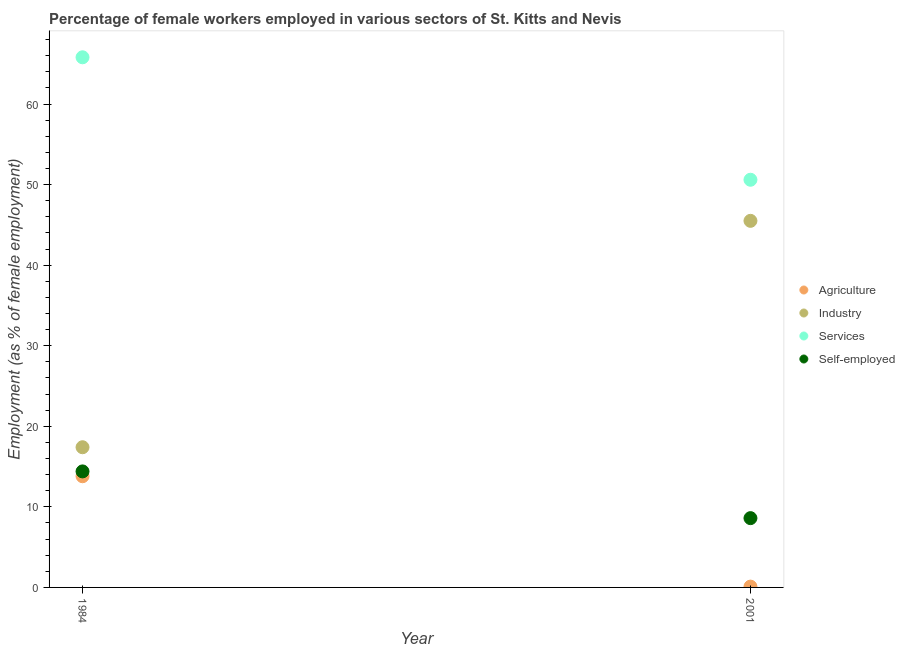Is the number of dotlines equal to the number of legend labels?
Give a very brief answer. Yes. What is the percentage of female workers in services in 1984?
Make the answer very short. 65.8. Across all years, what is the maximum percentage of female workers in industry?
Your response must be concise. 45.5. Across all years, what is the minimum percentage of self employed female workers?
Offer a very short reply. 8.6. In which year was the percentage of female workers in agriculture minimum?
Ensure brevity in your answer.  2001. What is the total percentage of female workers in agriculture in the graph?
Ensure brevity in your answer.  13.9. What is the difference between the percentage of self employed female workers in 1984 and that in 2001?
Give a very brief answer. 5.8. What is the difference between the percentage of self employed female workers in 2001 and the percentage of female workers in agriculture in 1984?
Provide a succinct answer. -5.2. What is the average percentage of female workers in services per year?
Your response must be concise. 58.2. In the year 2001, what is the difference between the percentage of female workers in services and percentage of self employed female workers?
Your response must be concise. 42. In how many years, is the percentage of female workers in services greater than 46 %?
Offer a terse response. 2. What is the ratio of the percentage of female workers in agriculture in 1984 to that in 2001?
Your answer should be compact. 138. Is the percentage of female workers in services in 1984 less than that in 2001?
Offer a terse response. No. Is it the case that in every year, the sum of the percentage of female workers in agriculture and percentage of female workers in industry is greater than the percentage of female workers in services?
Your answer should be very brief. No. Is the percentage of female workers in industry strictly greater than the percentage of female workers in agriculture over the years?
Offer a very short reply. Yes. Is the percentage of self employed female workers strictly less than the percentage of female workers in services over the years?
Provide a succinct answer. Yes. How many dotlines are there?
Provide a short and direct response. 4. Where does the legend appear in the graph?
Offer a very short reply. Center right. How many legend labels are there?
Your response must be concise. 4. What is the title of the graph?
Give a very brief answer. Percentage of female workers employed in various sectors of St. Kitts and Nevis. What is the label or title of the Y-axis?
Offer a terse response. Employment (as % of female employment). What is the Employment (as % of female employment) of Agriculture in 1984?
Offer a very short reply. 13.8. What is the Employment (as % of female employment) of Industry in 1984?
Your answer should be very brief. 17.4. What is the Employment (as % of female employment) of Services in 1984?
Provide a succinct answer. 65.8. What is the Employment (as % of female employment) in Self-employed in 1984?
Provide a short and direct response. 14.4. What is the Employment (as % of female employment) of Agriculture in 2001?
Your answer should be compact. 0.1. What is the Employment (as % of female employment) in Industry in 2001?
Keep it short and to the point. 45.5. What is the Employment (as % of female employment) of Services in 2001?
Make the answer very short. 50.6. What is the Employment (as % of female employment) in Self-employed in 2001?
Offer a very short reply. 8.6. Across all years, what is the maximum Employment (as % of female employment) in Agriculture?
Offer a terse response. 13.8. Across all years, what is the maximum Employment (as % of female employment) of Industry?
Provide a succinct answer. 45.5. Across all years, what is the maximum Employment (as % of female employment) in Services?
Provide a succinct answer. 65.8. Across all years, what is the maximum Employment (as % of female employment) in Self-employed?
Make the answer very short. 14.4. Across all years, what is the minimum Employment (as % of female employment) in Agriculture?
Your response must be concise. 0.1. Across all years, what is the minimum Employment (as % of female employment) of Industry?
Give a very brief answer. 17.4. Across all years, what is the minimum Employment (as % of female employment) in Services?
Offer a very short reply. 50.6. Across all years, what is the minimum Employment (as % of female employment) in Self-employed?
Provide a short and direct response. 8.6. What is the total Employment (as % of female employment) in Agriculture in the graph?
Provide a short and direct response. 13.9. What is the total Employment (as % of female employment) of Industry in the graph?
Offer a very short reply. 62.9. What is the total Employment (as % of female employment) in Services in the graph?
Offer a terse response. 116.4. What is the total Employment (as % of female employment) of Self-employed in the graph?
Provide a short and direct response. 23. What is the difference between the Employment (as % of female employment) in Industry in 1984 and that in 2001?
Make the answer very short. -28.1. What is the difference between the Employment (as % of female employment) in Self-employed in 1984 and that in 2001?
Make the answer very short. 5.8. What is the difference between the Employment (as % of female employment) of Agriculture in 1984 and the Employment (as % of female employment) of Industry in 2001?
Offer a very short reply. -31.7. What is the difference between the Employment (as % of female employment) of Agriculture in 1984 and the Employment (as % of female employment) of Services in 2001?
Keep it short and to the point. -36.8. What is the difference between the Employment (as % of female employment) of Industry in 1984 and the Employment (as % of female employment) of Services in 2001?
Provide a short and direct response. -33.2. What is the difference between the Employment (as % of female employment) of Services in 1984 and the Employment (as % of female employment) of Self-employed in 2001?
Your answer should be compact. 57.2. What is the average Employment (as % of female employment) of Agriculture per year?
Provide a short and direct response. 6.95. What is the average Employment (as % of female employment) of Industry per year?
Keep it short and to the point. 31.45. What is the average Employment (as % of female employment) of Services per year?
Keep it short and to the point. 58.2. What is the average Employment (as % of female employment) in Self-employed per year?
Make the answer very short. 11.5. In the year 1984, what is the difference between the Employment (as % of female employment) in Agriculture and Employment (as % of female employment) in Services?
Offer a very short reply. -52. In the year 1984, what is the difference between the Employment (as % of female employment) of Agriculture and Employment (as % of female employment) of Self-employed?
Your response must be concise. -0.6. In the year 1984, what is the difference between the Employment (as % of female employment) of Industry and Employment (as % of female employment) of Services?
Keep it short and to the point. -48.4. In the year 1984, what is the difference between the Employment (as % of female employment) of Industry and Employment (as % of female employment) of Self-employed?
Keep it short and to the point. 3. In the year 1984, what is the difference between the Employment (as % of female employment) in Services and Employment (as % of female employment) in Self-employed?
Give a very brief answer. 51.4. In the year 2001, what is the difference between the Employment (as % of female employment) of Agriculture and Employment (as % of female employment) of Industry?
Ensure brevity in your answer.  -45.4. In the year 2001, what is the difference between the Employment (as % of female employment) in Agriculture and Employment (as % of female employment) in Services?
Make the answer very short. -50.5. In the year 2001, what is the difference between the Employment (as % of female employment) of Industry and Employment (as % of female employment) of Self-employed?
Your answer should be very brief. 36.9. In the year 2001, what is the difference between the Employment (as % of female employment) of Services and Employment (as % of female employment) of Self-employed?
Your answer should be very brief. 42. What is the ratio of the Employment (as % of female employment) in Agriculture in 1984 to that in 2001?
Your answer should be very brief. 138. What is the ratio of the Employment (as % of female employment) in Industry in 1984 to that in 2001?
Offer a very short reply. 0.38. What is the ratio of the Employment (as % of female employment) in Services in 1984 to that in 2001?
Make the answer very short. 1.3. What is the ratio of the Employment (as % of female employment) in Self-employed in 1984 to that in 2001?
Your response must be concise. 1.67. What is the difference between the highest and the second highest Employment (as % of female employment) in Industry?
Give a very brief answer. 28.1. What is the difference between the highest and the second highest Employment (as % of female employment) of Self-employed?
Give a very brief answer. 5.8. What is the difference between the highest and the lowest Employment (as % of female employment) in Agriculture?
Your answer should be very brief. 13.7. What is the difference between the highest and the lowest Employment (as % of female employment) in Industry?
Your answer should be compact. 28.1. What is the difference between the highest and the lowest Employment (as % of female employment) of Services?
Your response must be concise. 15.2. 